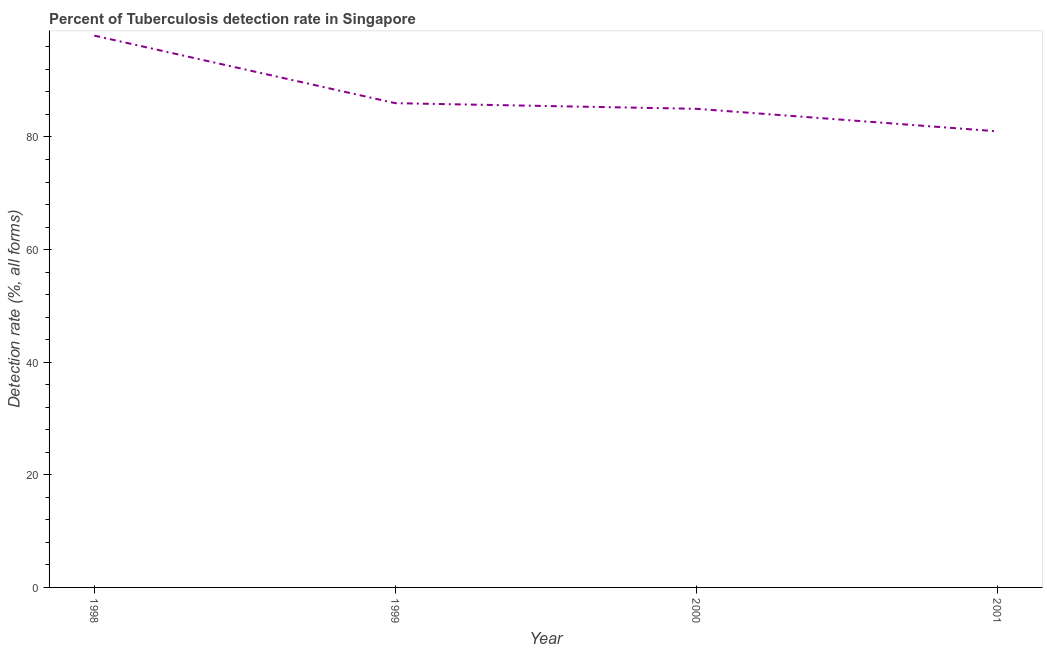What is the detection rate of tuberculosis in 1999?
Your response must be concise. 86. Across all years, what is the maximum detection rate of tuberculosis?
Your answer should be compact. 98. Across all years, what is the minimum detection rate of tuberculosis?
Offer a terse response. 81. In which year was the detection rate of tuberculosis minimum?
Make the answer very short. 2001. What is the sum of the detection rate of tuberculosis?
Provide a short and direct response. 350. What is the difference between the detection rate of tuberculosis in 1998 and 2000?
Your response must be concise. 13. What is the average detection rate of tuberculosis per year?
Provide a short and direct response. 87.5. What is the median detection rate of tuberculosis?
Provide a short and direct response. 85.5. What is the ratio of the detection rate of tuberculosis in 1998 to that in 2000?
Provide a succinct answer. 1.15. Is the difference between the detection rate of tuberculosis in 1998 and 2000 greater than the difference between any two years?
Give a very brief answer. No. Is the sum of the detection rate of tuberculosis in 1998 and 2001 greater than the maximum detection rate of tuberculosis across all years?
Your answer should be compact. Yes. What is the difference between the highest and the lowest detection rate of tuberculosis?
Provide a short and direct response. 17. Does the detection rate of tuberculosis monotonically increase over the years?
Keep it short and to the point. No. Does the graph contain grids?
Ensure brevity in your answer.  No. What is the title of the graph?
Ensure brevity in your answer.  Percent of Tuberculosis detection rate in Singapore. What is the label or title of the Y-axis?
Your answer should be compact. Detection rate (%, all forms). What is the Detection rate (%, all forms) of 1998?
Give a very brief answer. 98. What is the Detection rate (%, all forms) in 2000?
Your answer should be very brief. 85. What is the difference between the Detection rate (%, all forms) in 1998 and 2000?
Keep it short and to the point. 13. What is the difference between the Detection rate (%, all forms) in 1998 and 2001?
Make the answer very short. 17. What is the difference between the Detection rate (%, all forms) in 1999 and 2001?
Make the answer very short. 5. What is the ratio of the Detection rate (%, all forms) in 1998 to that in 1999?
Your answer should be very brief. 1.14. What is the ratio of the Detection rate (%, all forms) in 1998 to that in 2000?
Keep it short and to the point. 1.15. What is the ratio of the Detection rate (%, all forms) in 1998 to that in 2001?
Your response must be concise. 1.21. What is the ratio of the Detection rate (%, all forms) in 1999 to that in 2001?
Make the answer very short. 1.06. What is the ratio of the Detection rate (%, all forms) in 2000 to that in 2001?
Provide a short and direct response. 1.05. 